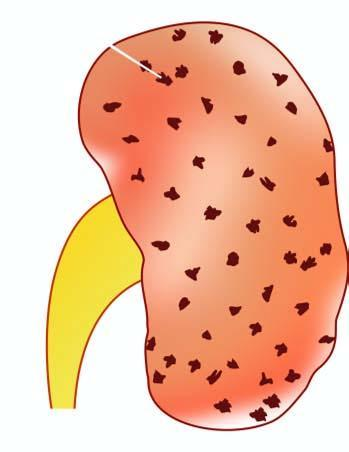does the cortex show characteristic 'flea bitten kidney ' due to tiny petechial haemorrhages on the surface?
Answer the question using a single word or phrase. Yes 